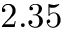<formula> <loc_0><loc_0><loc_500><loc_500>2 . 3 5</formula> 